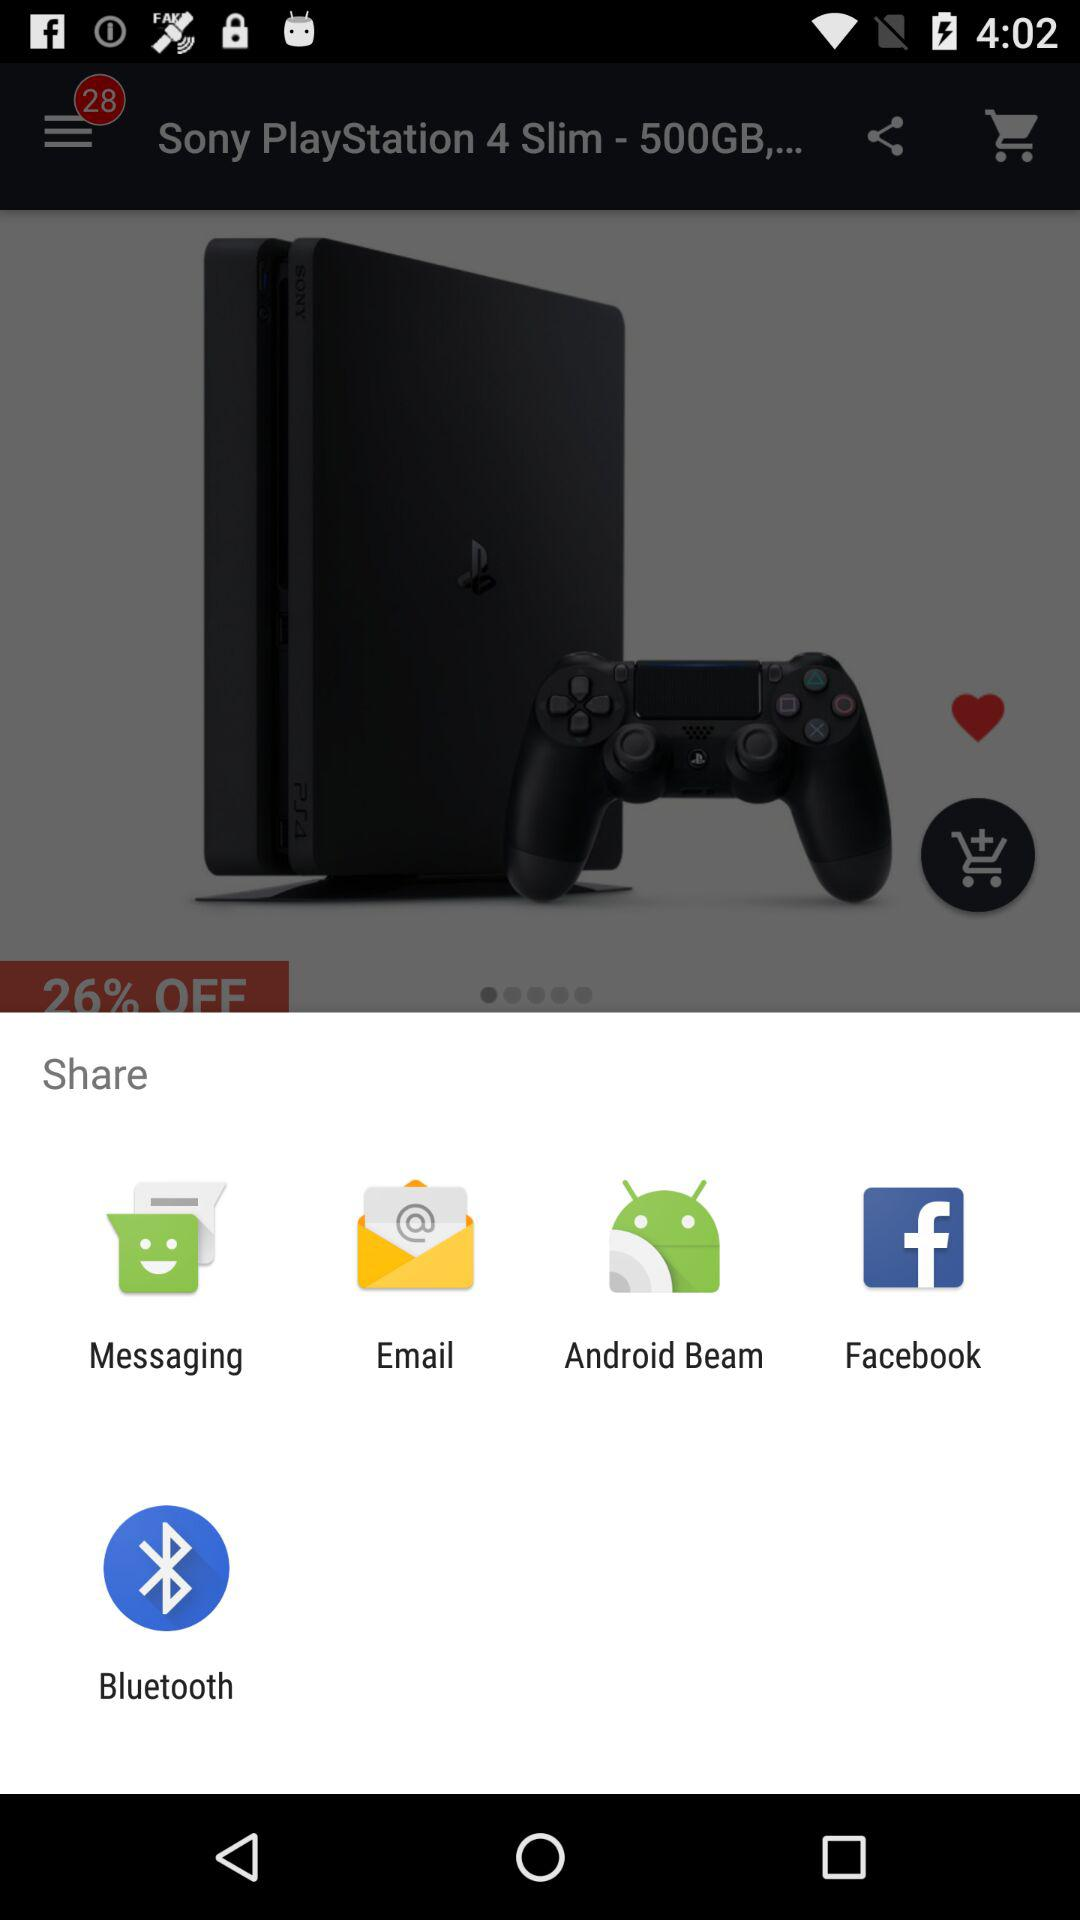Through which applications can the content be shared? The content can be shared through "Messaging", "Email", "Android Beam", "Facebook" and "Bluetooth". 